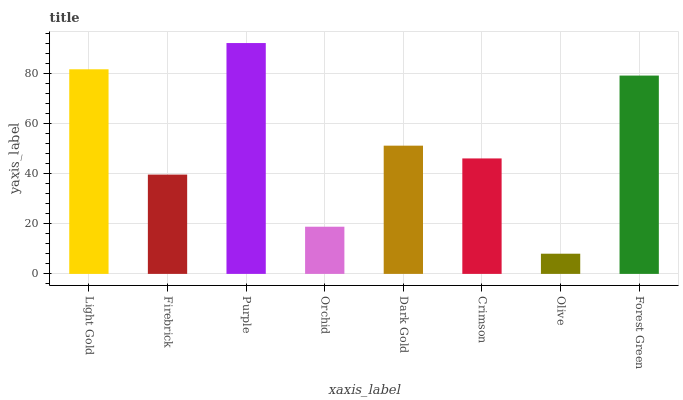Is Olive the minimum?
Answer yes or no. Yes. Is Purple the maximum?
Answer yes or no. Yes. Is Firebrick the minimum?
Answer yes or no. No. Is Firebrick the maximum?
Answer yes or no. No. Is Light Gold greater than Firebrick?
Answer yes or no. Yes. Is Firebrick less than Light Gold?
Answer yes or no. Yes. Is Firebrick greater than Light Gold?
Answer yes or no. No. Is Light Gold less than Firebrick?
Answer yes or no. No. Is Dark Gold the high median?
Answer yes or no. Yes. Is Crimson the low median?
Answer yes or no. Yes. Is Crimson the high median?
Answer yes or no. No. Is Orchid the low median?
Answer yes or no. No. 